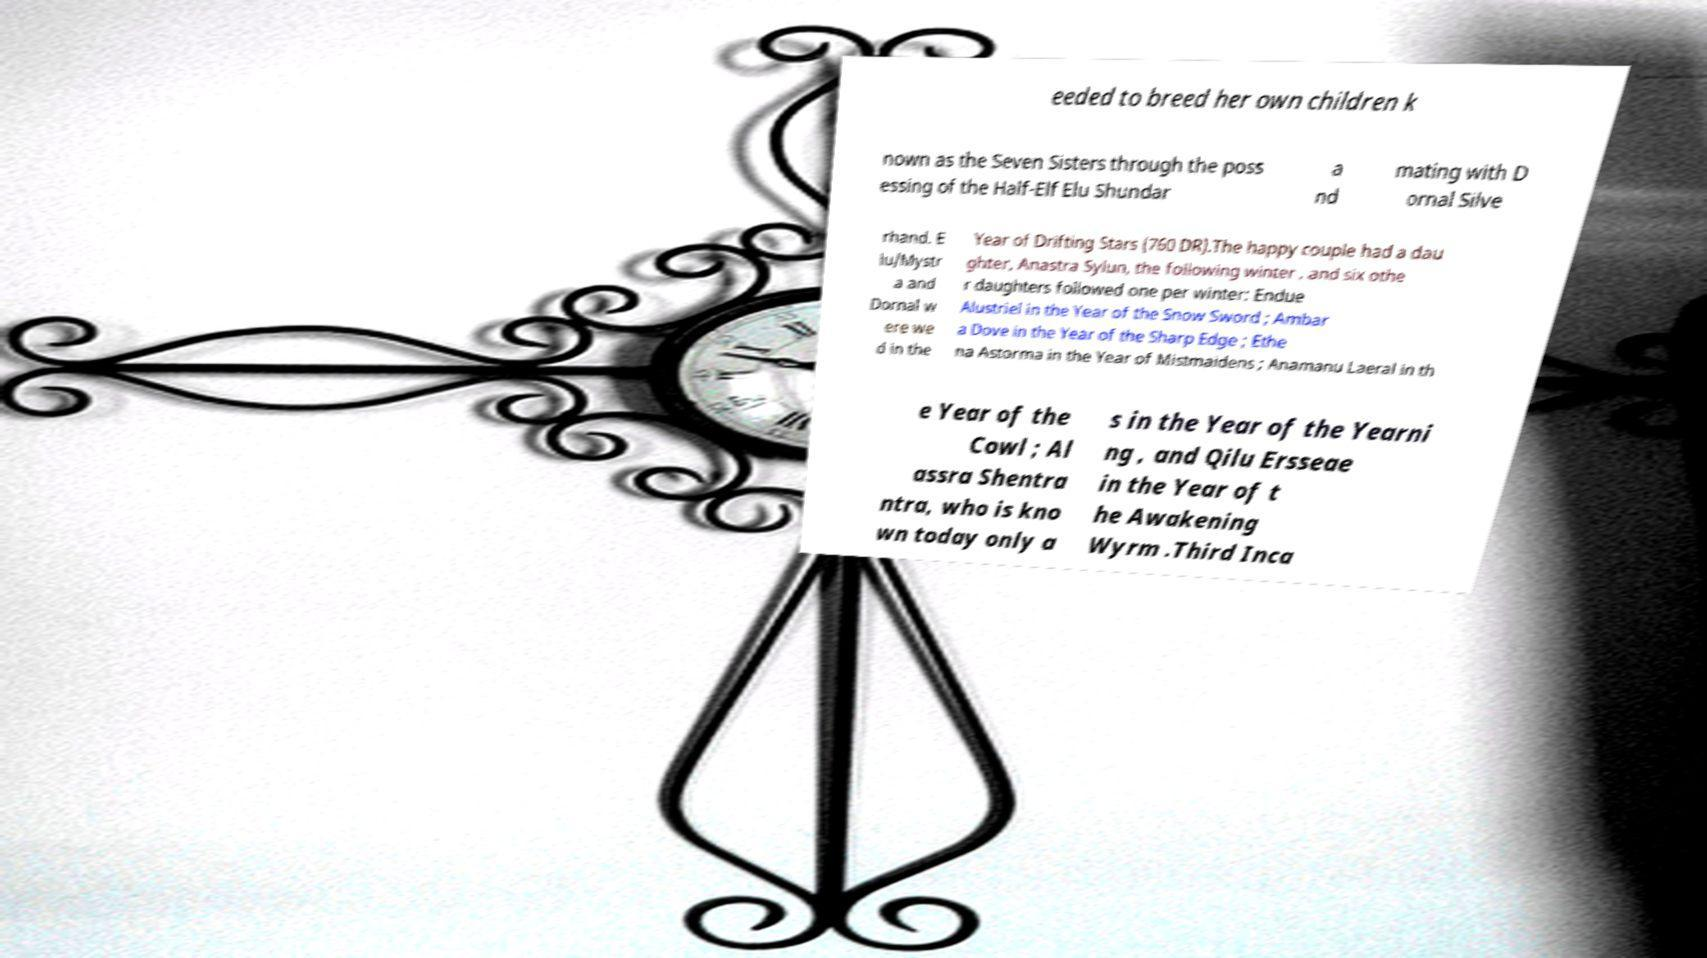There's text embedded in this image that I need extracted. Can you transcribe it verbatim? eeded to breed her own children k nown as the Seven Sisters through the poss essing of the Half-Elf Elu Shundar a nd mating with D ornal Silve rhand. E lu/Mystr a and Dornal w ere we d in the Year of Drifting Stars (760 DR).The happy couple had a dau ghter, Anastra Sylun, the following winter , and six othe r daughters followed one per winter: Endue Alustriel in the Year of the Snow Sword ; Ambar a Dove in the Year of the Sharp Edge ; Ethe na Astorma in the Year of Mistmaidens ; Anamanu Laeral in th e Year of the Cowl ; Al assra Shentra ntra, who is kno wn today only a s in the Year of the Yearni ng , and Qilu Ersseae in the Year of t he Awakening Wyrm .Third Inca 